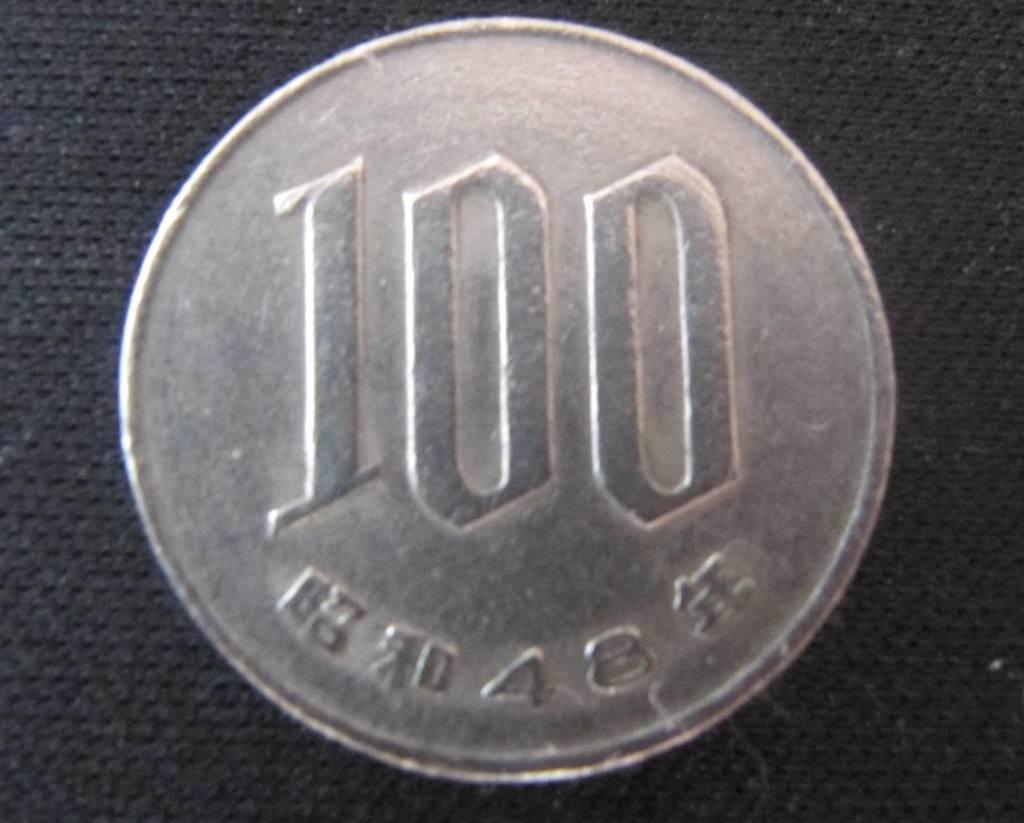What is the value of the coin?
Offer a very short reply. 100. What number is written across the bottom?
Provide a short and direct response. 48. 